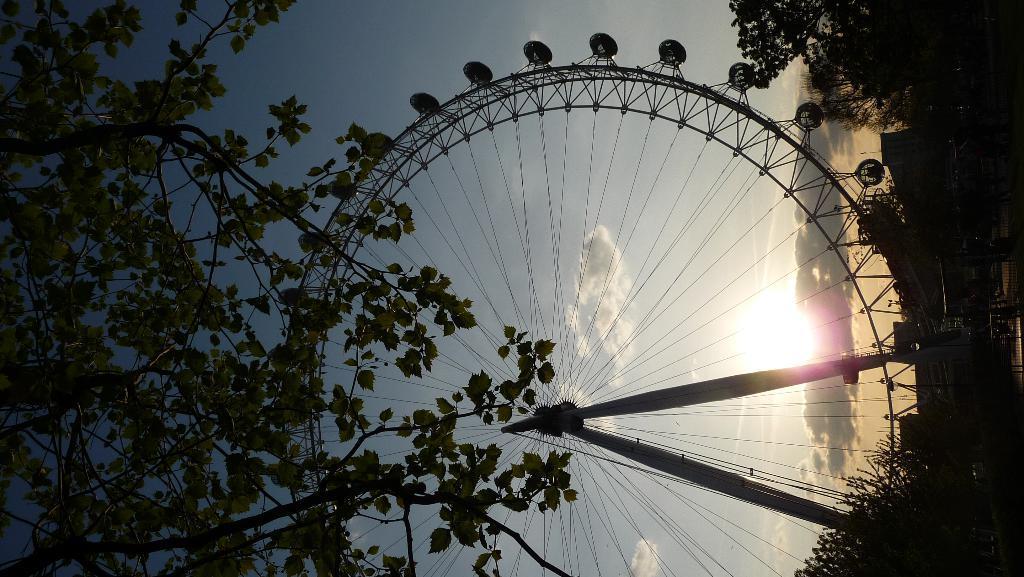Please provide a concise description of this image. In this image there is the sky towards the top of the image, there are clouds in the sky, there are clouds in the sky, there is a giant wheel towards the bottom of the image, there are trees towards the right of the image, there is a tree towards the left of the image. 